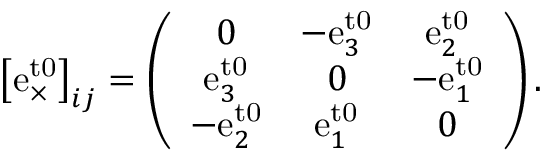<formula> <loc_0><loc_0><loc_500><loc_500>\left [ e _ { \times } ^ { t 0 } \right ] _ { i j } = \left ( \begin{array} { c c c } { 0 } & { - e _ { 3 } ^ { t 0 } } & { e _ { 2 } ^ { t 0 } } \\ { e _ { 3 } ^ { t 0 } } & { 0 } & { - e _ { 1 } ^ { t 0 } } \\ { - e _ { 2 } ^ { t 0 } } & { e _ { 1 } ^ { t 0 } } & { 0 } \end{array} \right ) .</formula> 